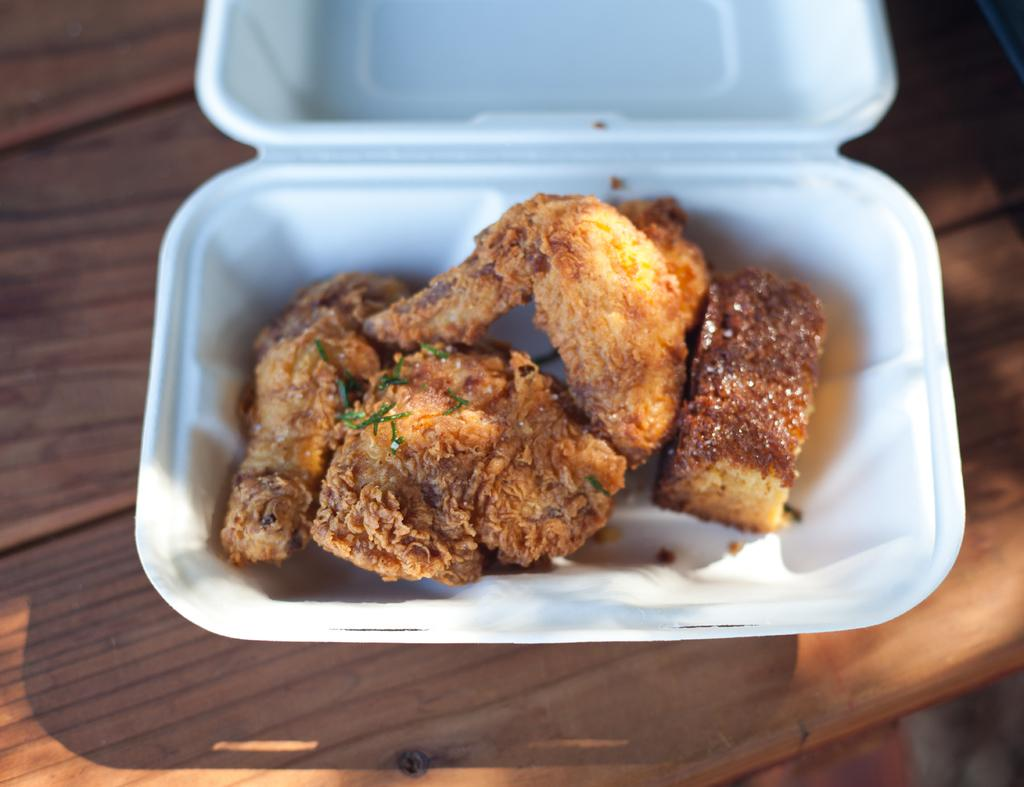What is the main object in the image? There is a white color box in the image. What is inside the white color box? The white color box contains food places. Can you describe the food in the image? The food is brown in color. What is the color of the table in the image? There is a brown color table in the image. What type of pipe can be seen in the image? There is no pipe present in the image. Is the image depicting a winter scene? The image does not provide any information about the season, so it cannot be determined if it is a winter scene. 